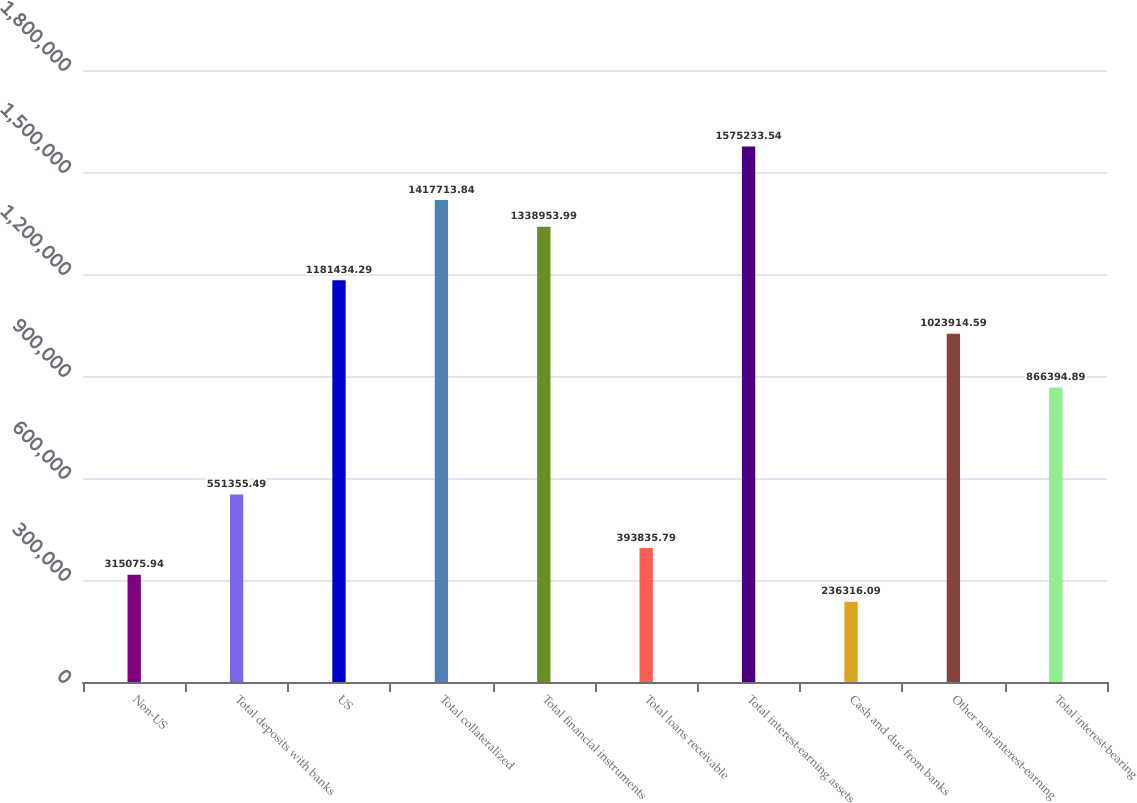<chart> <loc_0><loc_0><loc_500><loc_500><bar_chart><fcel>Non-US<fcel>Total deposits with banks<fcel>US<fcel>Total collateralized<fcel>Total financial instruments<fcel>Total loans receivable<fcel>Total interest-earning assets<fcel>Cash and due from banks<fcel>Other non-interest-earning<fcel>Total interest-bearing<nl><fcel>315076<fcel>551355<fcel>1.18143e+06<fcel>1.41771e+06<fcel>1.33895e+06<fcel>393836<fcel>1.57523e+06<fcel>236316<fcel>1.02391e+06<fcel>866395<nl></chart> 